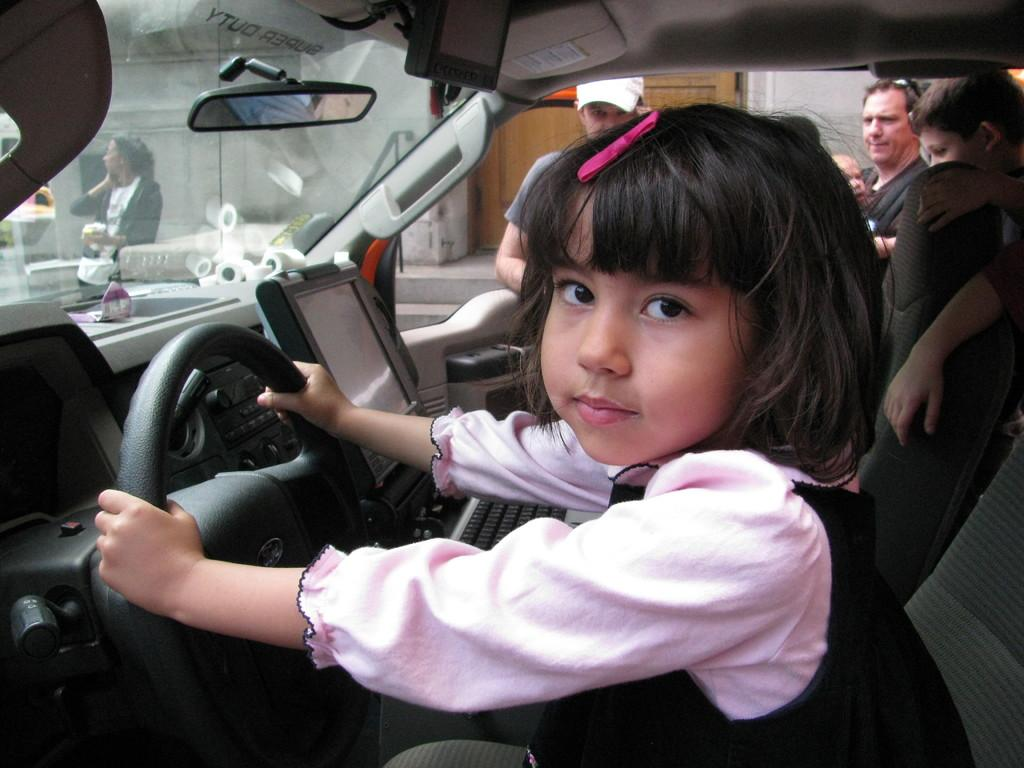Who is the main subject in the image? There is a child in the image. What is the child doing in the image? The child is sitting in a car and holding a steering wheel. Are there any other people visible in the image? Yes, there are people standing in the background of the image. What mark does the child have on their neck in the image? There is no mark visible on the child's neck in the image. What subject is the child teaching to the people in the background? The image does not show the child teaching any subject to the people in the background. 